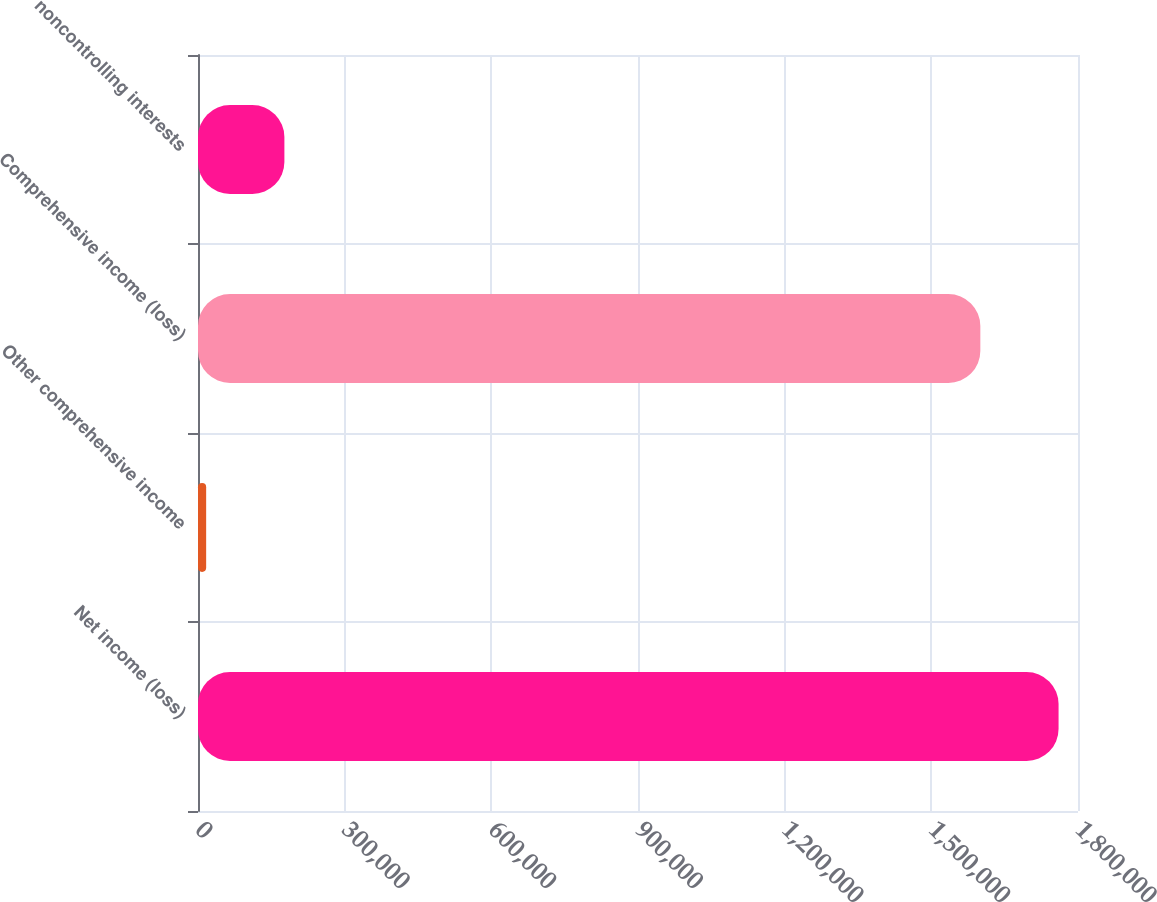Convert chart. <chart><loc_0><loc_0><loc_500><loc_500><bar_chart><fcel>Net income (loss)<fcel>Other comprehensive income<fcel>Comprehensive income (loss)<fcel>noncontrolling interests<nl><fcel>1.76026e+06<fcel>16679<fcel>1.60023e+06<fcel>176702<nl></chart> 